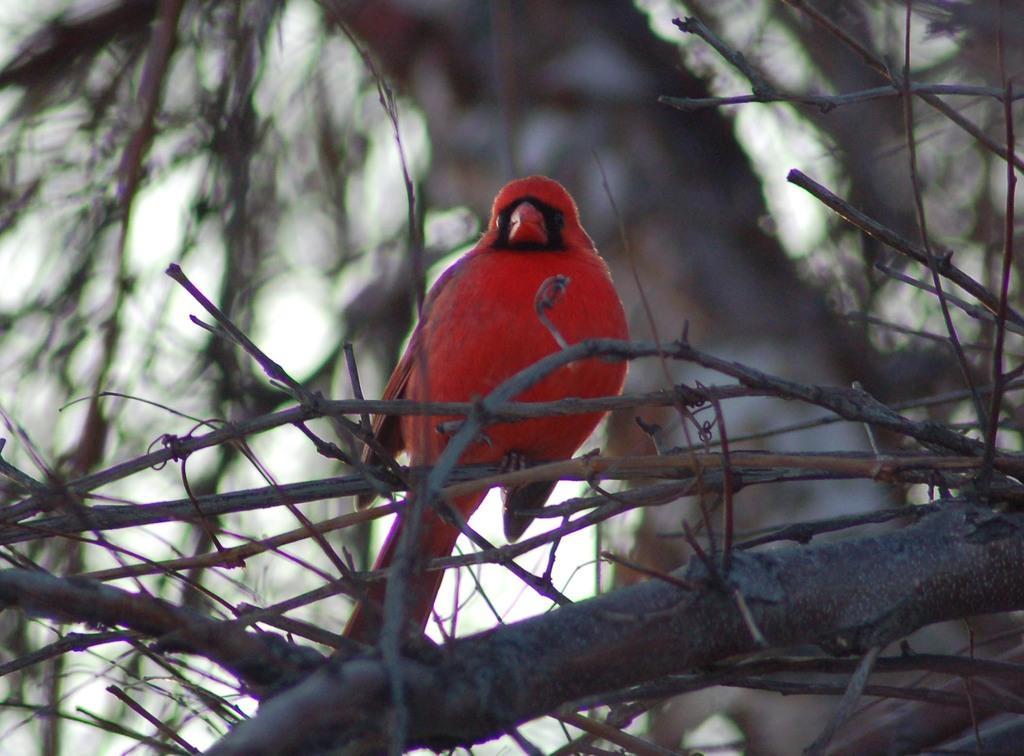In one or two sentences, can you explain what this image depicts? We can see red bird on stem. Background it is blurry and we can see sky. 